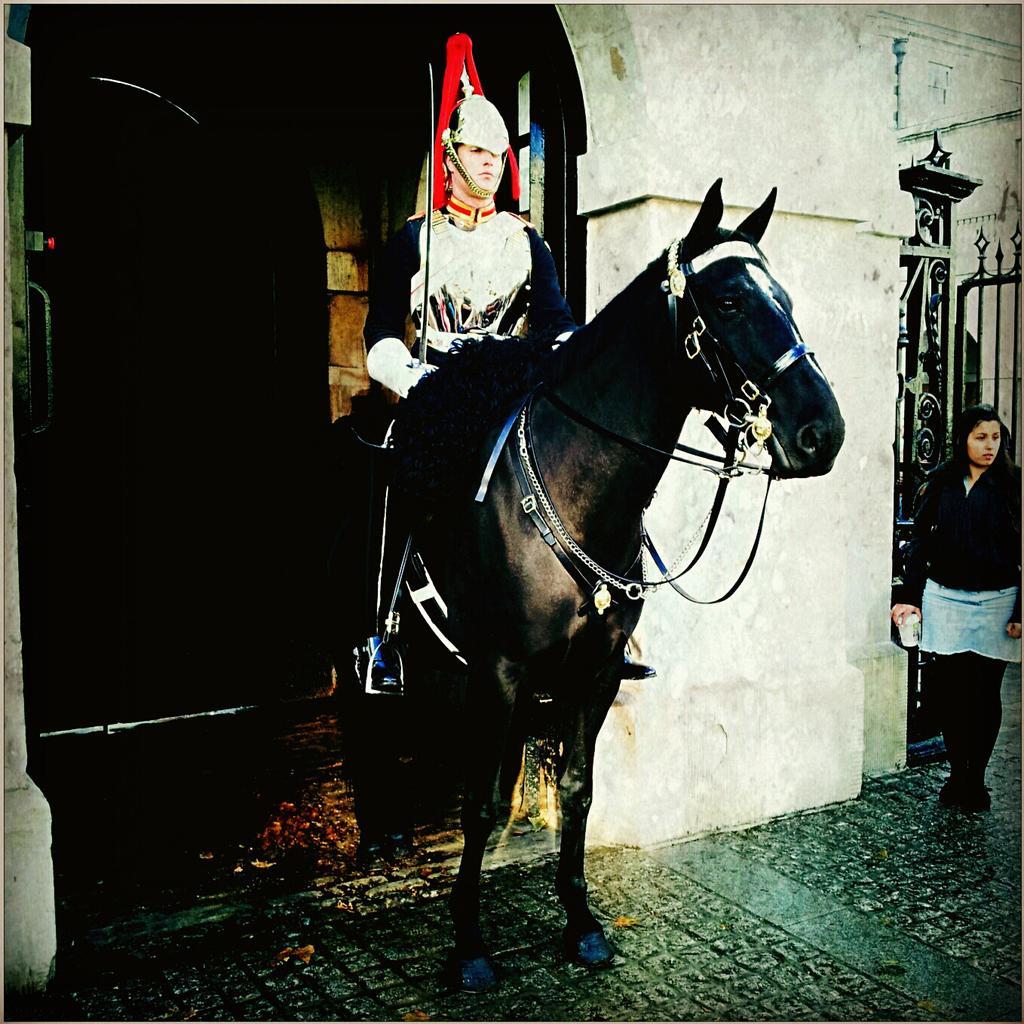Describe this image in one or two sentences. Here is a man holding a sword and sitting on the horse. At the right side of the image I can see a woman standing. At background, this looks like a door. 